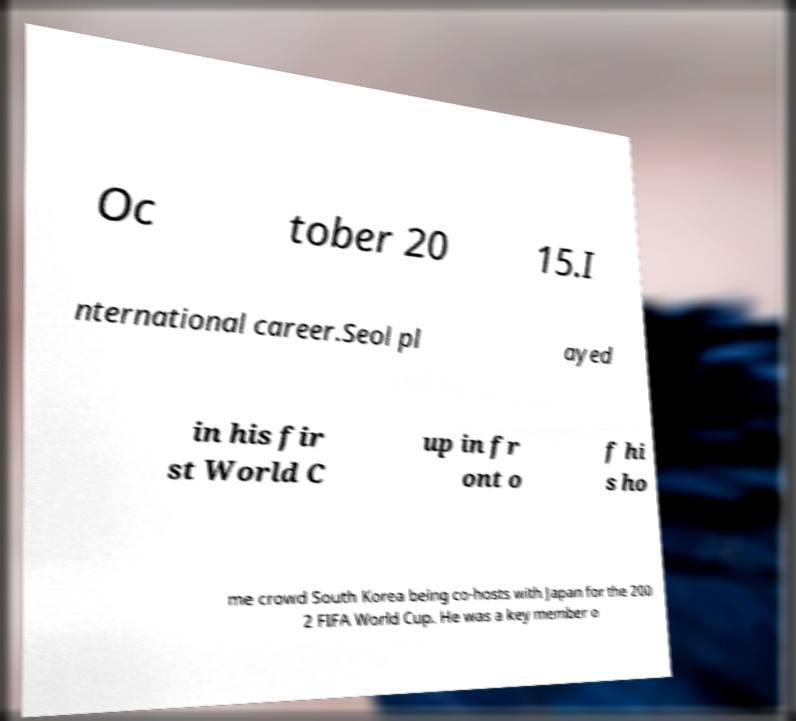Can you read and provide the text displayed in the image?This photo seems to have some interesting text. Can you extract and type it out for me? Oc tober 20 15.I nternational career.Seol pl ayed in his fir st World C up in fr ont o f hi s ho me crowd South Korea being co-hosts with Japan for the 200 2 FIFA World Cup. He was a key member o 